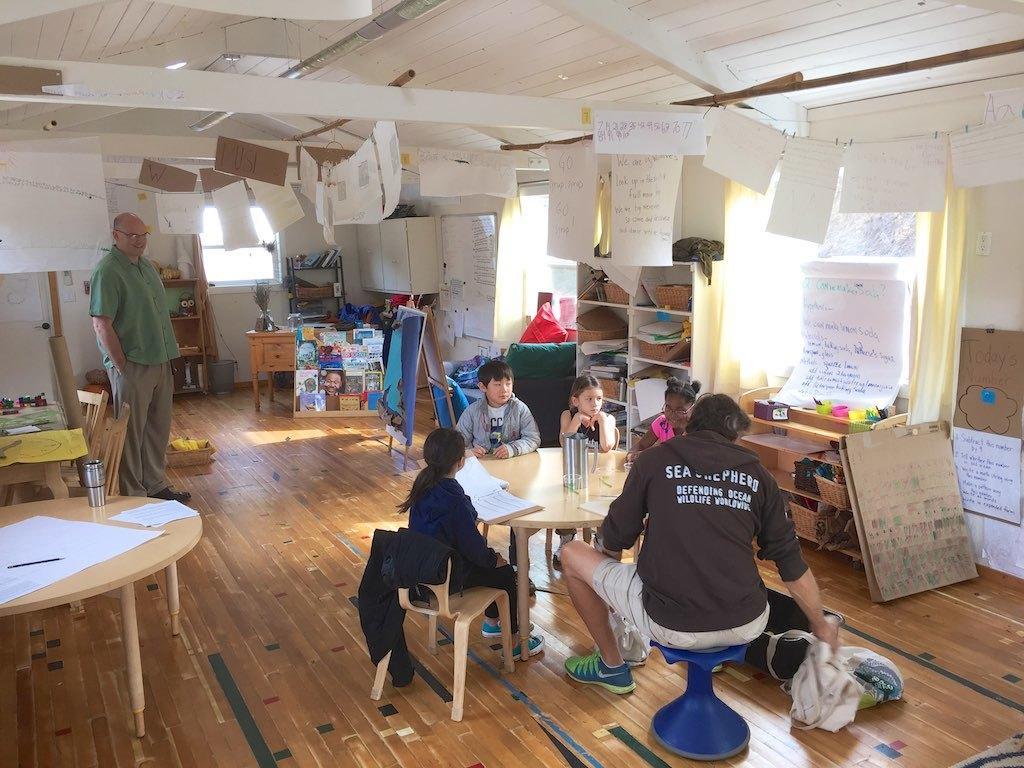Can you describe this image briefly? In the image there are kids sat on chair around the table and in front there is a man sat and at left corner there is a old man stood and all around the room there are charts,this seems to be a playschool. 